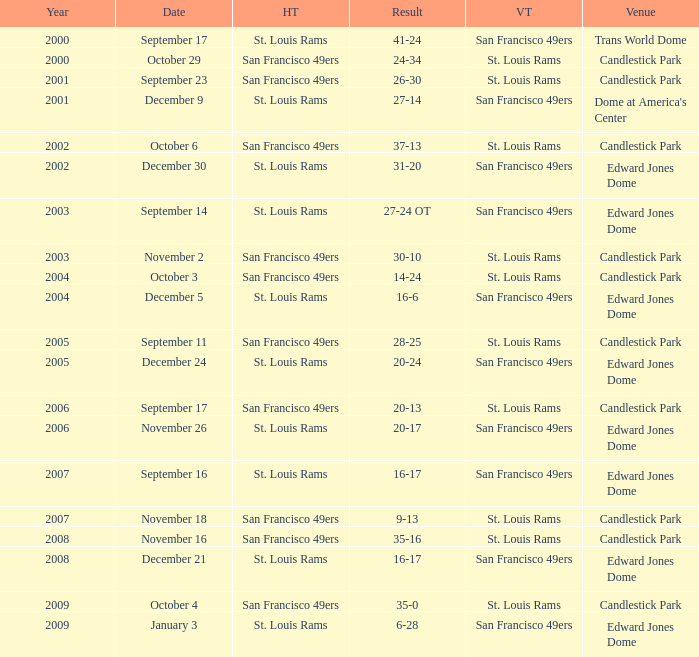What was the Venue of the San Francisco 49ers Home game with a Result of 30-10? Candlestick Park. 